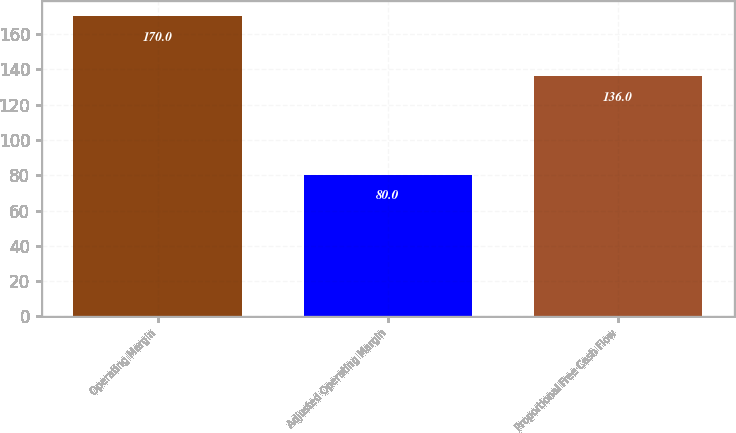Convert chart. <chart><loc_0><loc_0><loc_500><loc_500><bar_chart><fcel>Operating Margin<fcel>Adjusted Operating Margin<fcel>Proportional Free Cash Flow<nl><fcel>170<fcel>80<fcel>136<nl></chart> 